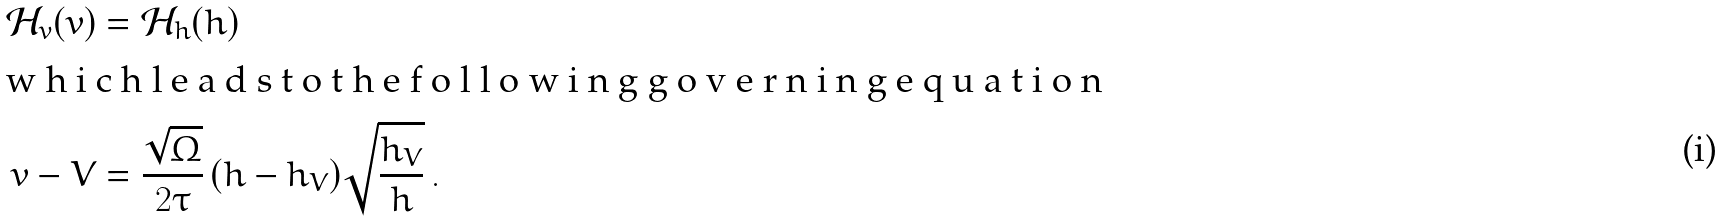<formula> <loc_0><loc_0><loc_500><loc_500>\mathcal { H } _ { v } ( v ) & = \mathcal { H } _ { h } ( h ) \\ \intertext { w h i c h l e a d s t o t h e f o l l o w i n g g o v e r n i n g e q u a t i o n } v - V & = \frac { \sqrt { \Omega } } { 2 \tau } \, ( h - h _ { V } ) \sqrt { \frac { h _ { V } } { h } } \, .</formula> 